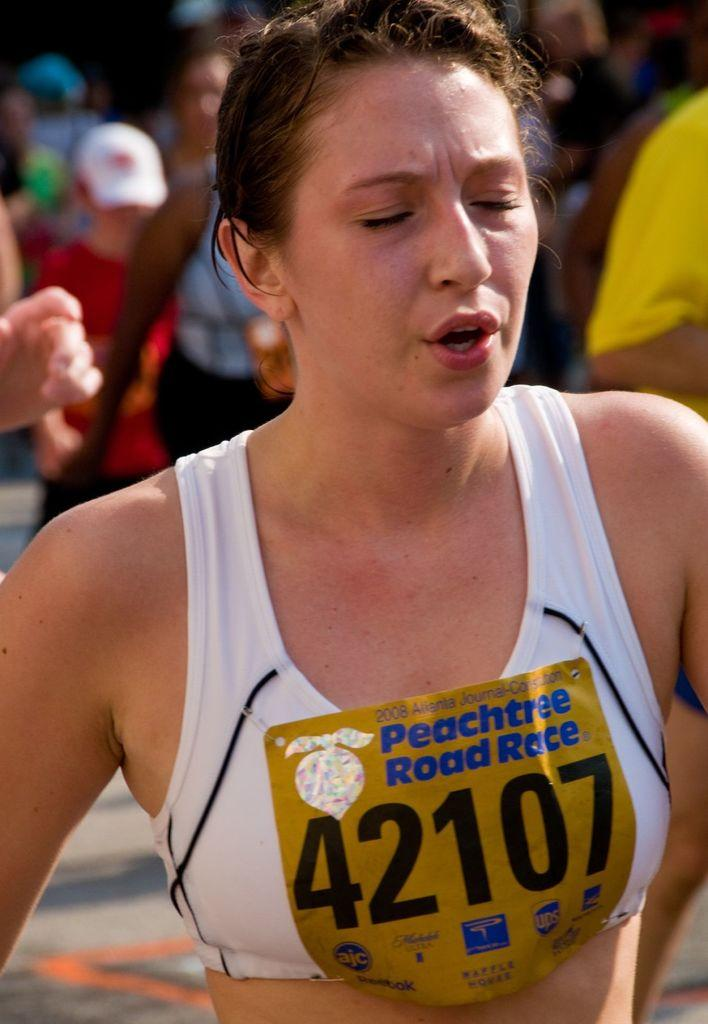<image>
Provide a brief description of the given image. A girl is running with her eyes closed and she has a sign on that says 42107. 